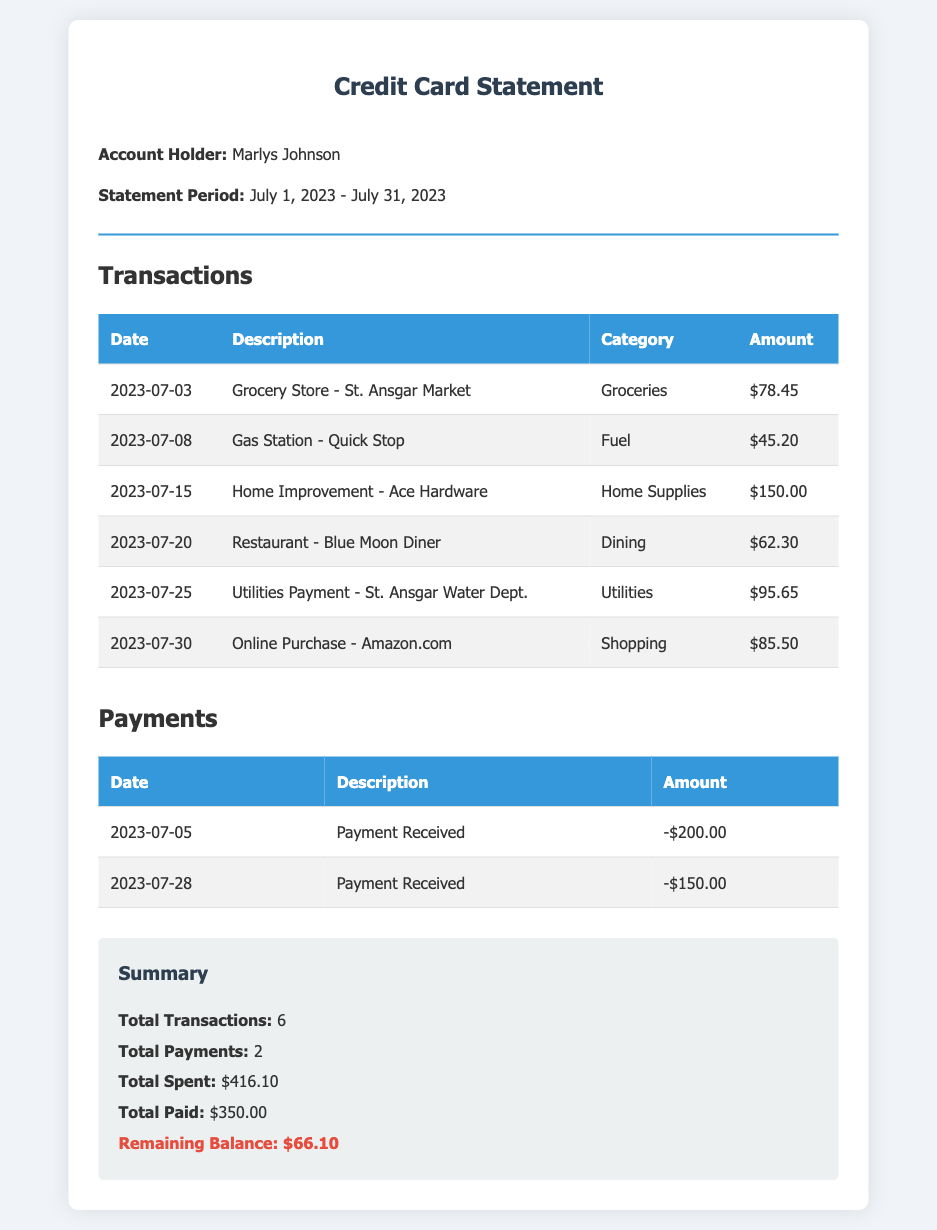What is the statement period? The statement period indicates the time frame for which the transactions are recorded and is from July 1, 2023, to July 31, 2023.
Answer: July 1, 2023 - July 31, 2023 How much was spent on groceries? The transaction for groceries on July 3, 2023, was $78.45.
Answer: $78.45 What is the total amount paid during July 2023? The total payments made were $200.00 on July 5 and $150.00 on July 28, which totals to $350.00.
Answer: $350.00 How many transactions are listed in total? The document summarizes that there are a total of 6 transactions for the statement period.
Answer: 6 What is the remaining balance? The remaining balance after all transactions and payments is highlighted in the summary as $66.10.
Answer: $66.10 What category does the Ace Hardware transaction fall under? The transaction from Ace Hardware is categorized as home supplies.
Answer: Home Supplies When was the last payment received? The last payment recorded in the document was received on July 28, 2023.
Answer: July 28, 2023 Which utility payment is mentioned in the transactions? The utility payment is made to the St. Ansgar Water Department.
Answer: St. Ansgar Water Dept What was the description for the online purchase? The description for the online purchase states it was made at Amazon.com.
Answer: Amazon.com 